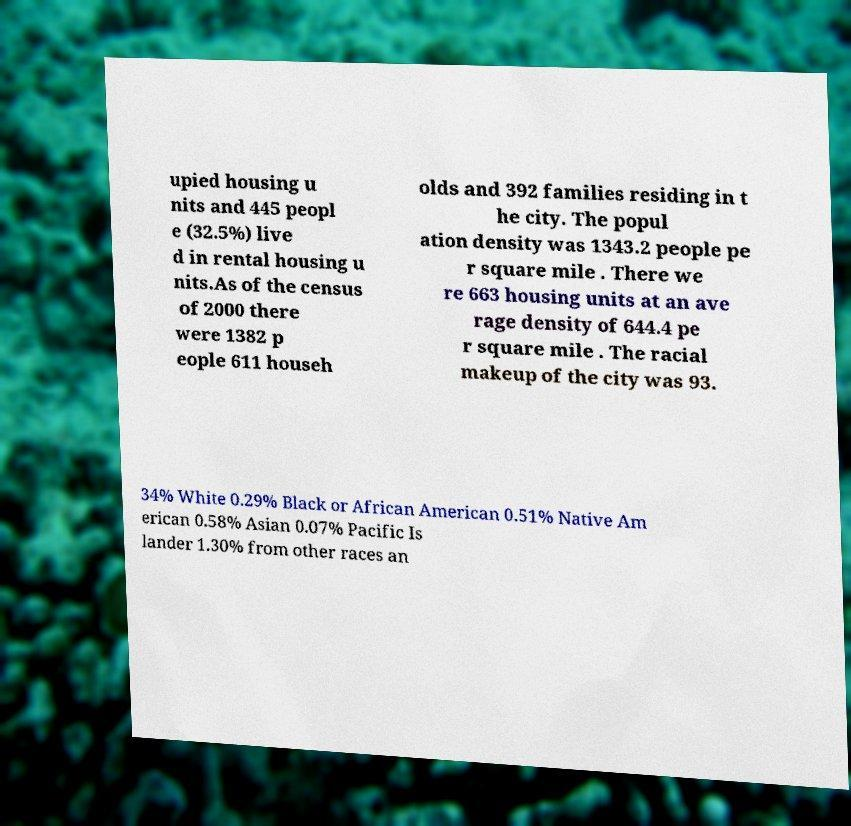I need the written content from this picture converted into text. Can you do that? upied housing u nits and 445 peopl e (32.5%) live d in rental housing u nits.As of the census of 2000 there were 1382 p eople 611 househ olds and 392 families residing in t he city. The popul ation density was 1343.2 people pe r square mile . There we re 663 housing units at an ave rage density of 644.4 pe r square mile . The racial makeup of the city was 93. 34% White 0.29% Black or African American 0.51% Native Am erican 0.58% Asian 0.07% Pacific Is lander 1.30% from other races an 